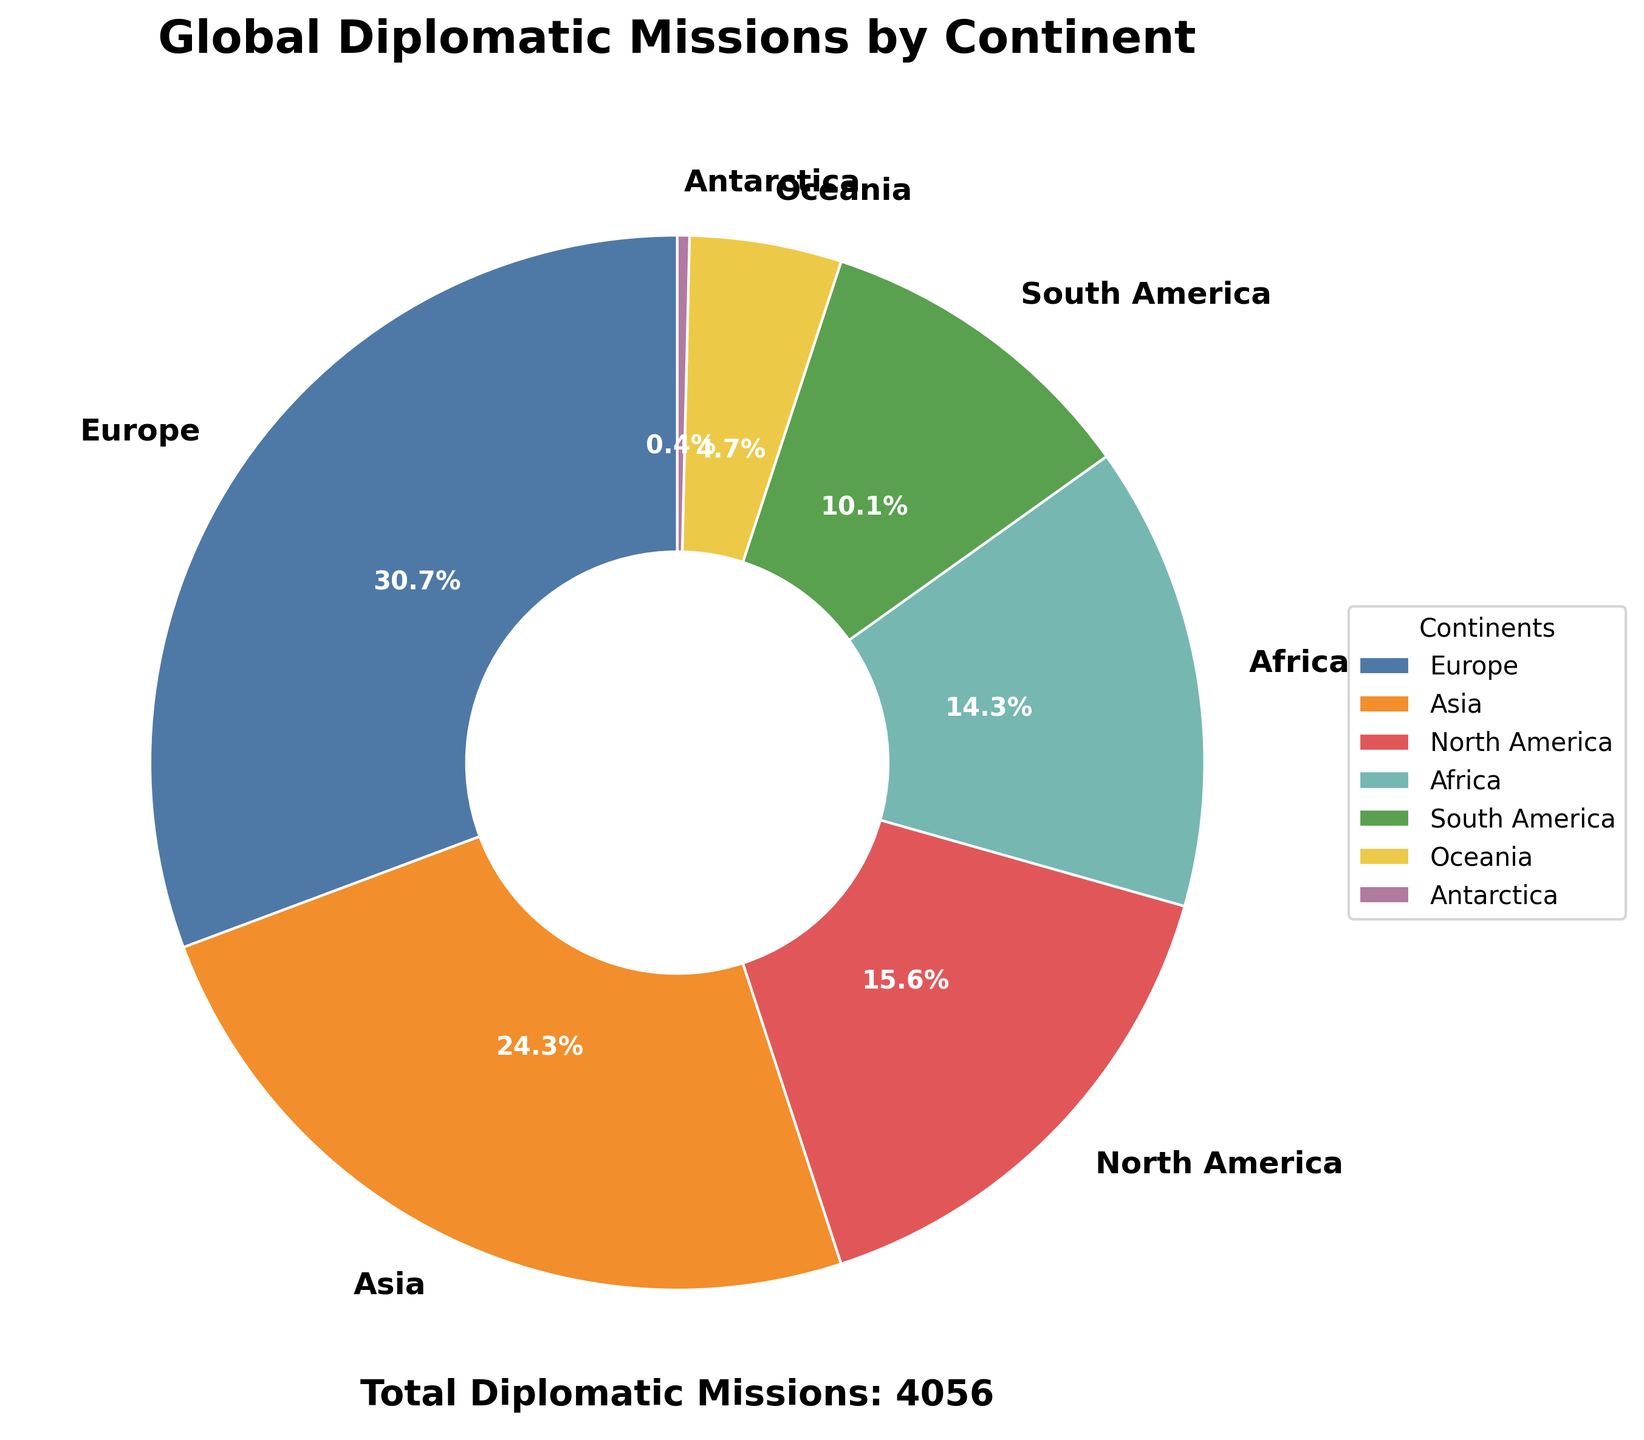Which continent has the highest number of diplomatic missions? The figure shows a pie chart with a section labeled "Europe" taking up the largest area. This indicates that Europe has the highest number of diplomatic missions.
Answer: Europe Which continent contributes the least to the global count of diplomatic missions? The smallest section in the pie chart is labeled "Antarctica," indicating it contributes the least to the total number of diplomatic missions.
Answer: Antarctica What is the approximate percentage of North America's diplomatic missions relative to the global total? North America's section of the pie chart is labeled with its percentage, which is about 15.3%.
Answer: 15.3% By how much do Europe's diplomatic missions exceed those in South America? Europe's slice is significantly larger than South America's. Numerically, Europe has 1245 missions, and South America has 410 missions. The difference is 1245 - 410 = 835.
Answer: 835 What's the combined percentage of diplomatic missions in Africa and Oceania? The chart provides the percentages for Africa (7.1%) and Oceania (2.3%). Adding these together gives 7.1% + 2.3% = 9.4%.
Answer: 9.4% Compare the number of diplomatic missions in Asia to those in North America. Which continent has more, and by how many? Asia's slice is larger than North America's. Asia has 987 missions, while North America has 632 missions. The difference is 987 - 632 = 355.
Answer: Asia, 355 Which continents have more than 10% of the total diplomatic missions each? From the pie chart, Europe (approximated at around 32.8%) and Asia (approximated at around 26.0%) clearly have more than 10% each.
Answer: Europe, Asia Calculate the total number of diplomatic missions for continents other than Europe and Asia. Summing the missions for North America (632), Africa (578), South America (410), Oceania (189), and Antarctica (15) equals 632 + 578 + 410 + 189 + 15 = 1824 missions.
Answer: 1824 What percentage of the total diplomatic missions is not located in Asia? The percentage for Asia is approximately 26%. Therefore, the percentage not in Asia is 100% - 26% = 74%.
Answer: 74% What is the ratio of diplomatic missions between Africa and Oceania? Africa has 578 missions, and Oceania has 189 missions. The ratio is 578:189. Simplifying this ratio using the greatest common divisor (GCD), the ratio is approximately 3.06:1.
Answer: 3.06:1 